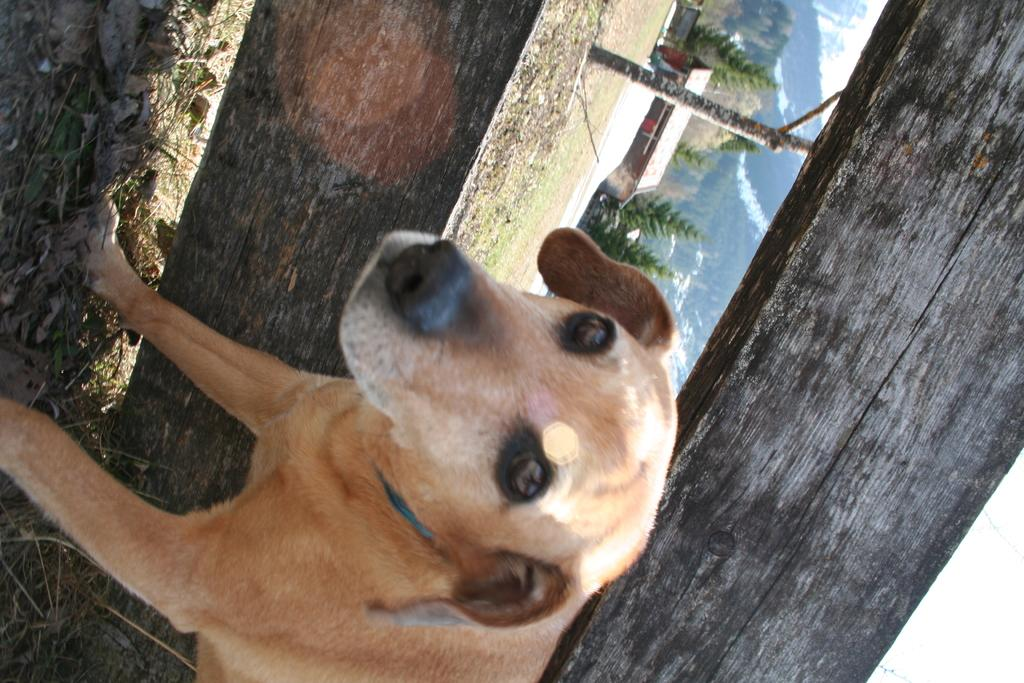What type of animal is in the image? There is a dog in the image. What is behind the dog? There is wooden fencing behind the dog. What can be seen in the background of the image? Trees, hills, and a building are visible in the background of the image. What type of card is the dog holding in the image? There is no card present in the image; the dog is not holding anything. 